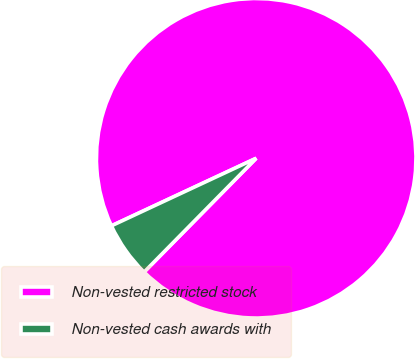<chart> <loc_0><loc_0><loc_500><loc_500><pie_chart><fcel>Non-vested restricted stock<fcel>Non-vested cash awards with<nl><fcel>94.33%<fcel>5.67%<nl></chart> 